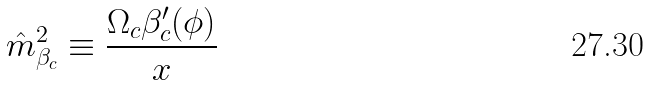Convert formula to latex. <formula><loc_0><loc_0><loc_500><loc_500>\hat { m } ^ { 2 } _ { \beta _ { c } } \equiv \frac { \Omega _ { c } \beta ^ { \prime } _ { c } ( \phi ) } { x }</formula> 